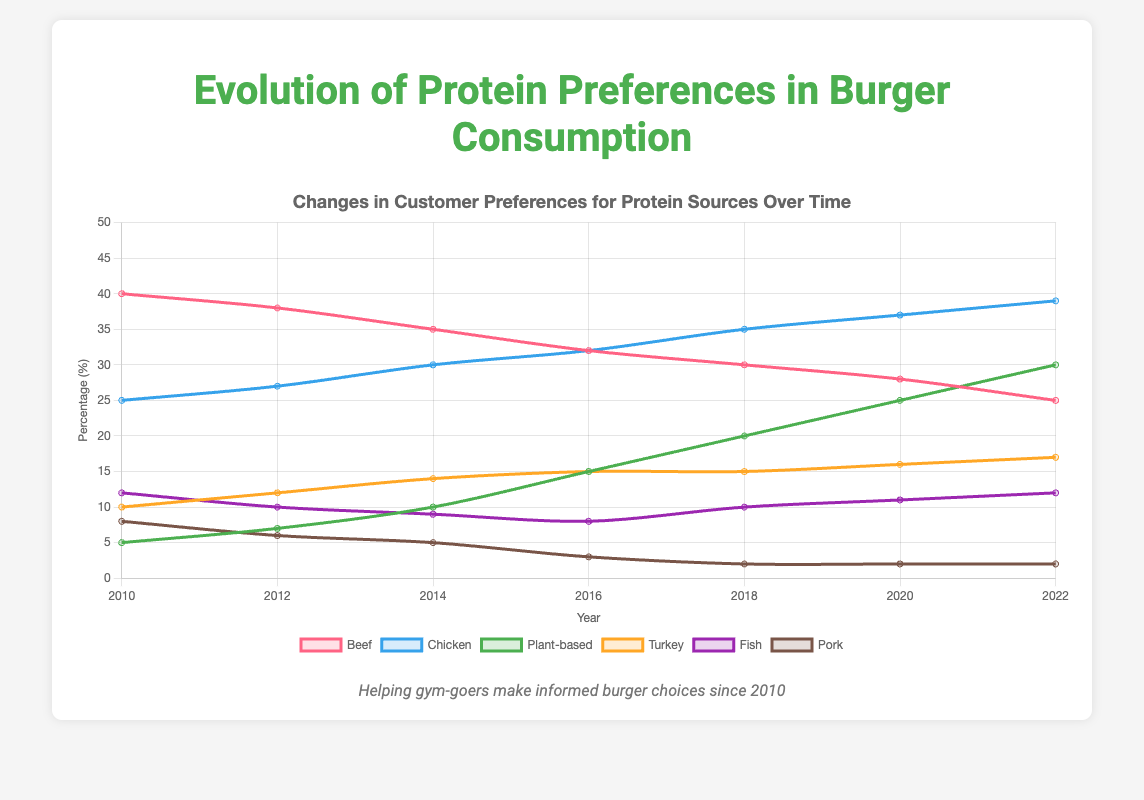What was the most popular protein source in 2010? In 2010, the data shows that beef had the highest percentage compared to other protein sources.
Answer: Beef Which protein source showed the greatest increase in preference between 2010 and 2022? By comparing the percentages from 2010 and 2022 for all protein sources, plant-based proteins had the most significant increase, from 5% to 30%.
Answer: Plant-based How many protein sources had a decrease in customer preference from 2010 to 2022? A decrease in customer preference can be observed in beef, fish, and pork by comparing their values from 2010 to 2022.
Answer: 3 By how many percentage points did the preference for chicken change from 2010 to 2022? The preference for chicken increased from 25% in 2010 to 39% in 2022. The change is 39 - 25 = 14 percentage points.
Answer: 14 Which protein sources had a consistent increase in preference over the years? Observing the trend lines, chicken, plant-based, and turkey all showed a steady increase throughout the period from 2010 to 2022.
Answer: Chicken, plant-based, turkey In which year did the preference for fish reach its lowest point? The preference for fish was the lowest at 8% in the year 2016.
Answer: 2016 Considering 2022, which two protein sources had the closest percentage preferences? In 2022, turkey was at 17% and fish was at 12%. The closest comparison among others is plant-based at 30% and beef at 25% with a 5% difference.
Answer: Beef and plant-based What is the average customer preference percentage for beef from 2010 to 2022? The sum of the percentages for beef from 2010 to 2022 is (40 + 38 + 35 + 32 + 30 + 28 + 25) = 228. The average is 228 / 7.
Answer: 32.57 Based on the changes from 2010 to 2022, which protein source would you predict might surpass chicken in the next few years if current trends continue? Considering the upward trends, plant-based protein, which increased from 5% to 30%, might surpass chicken soon if current growth trajectories persist.
Answer: Plant-based 